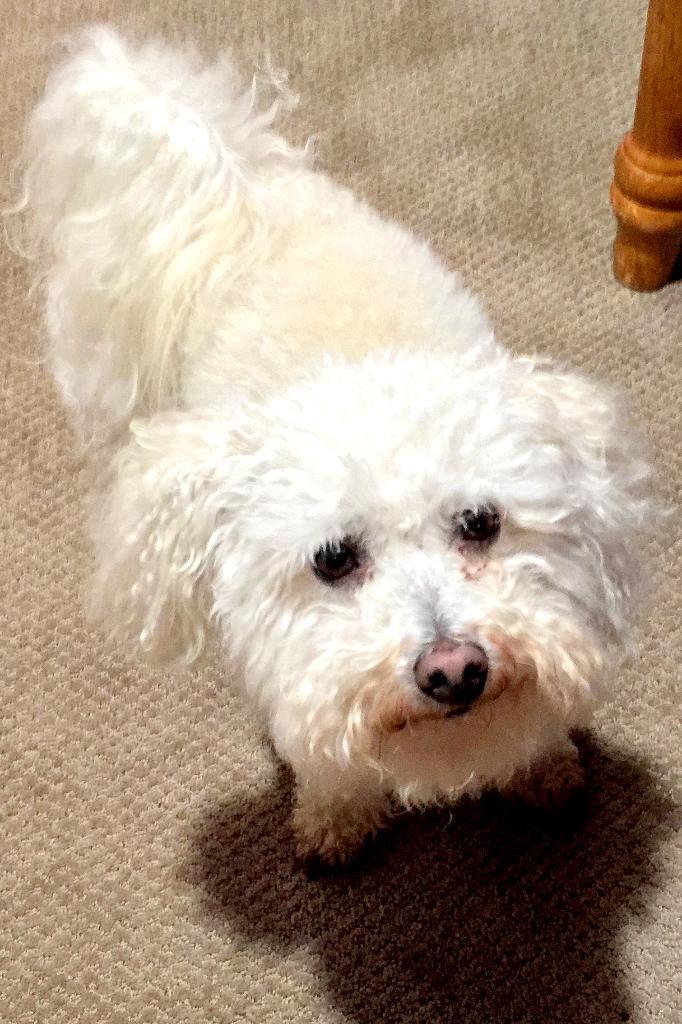In one or two sentences, can you explain what this image depicts? In the center of the image there is a carpet. On the carpet, we can see one dog, which is in a white color. At the top right side of the image, we can see a wooden object. 